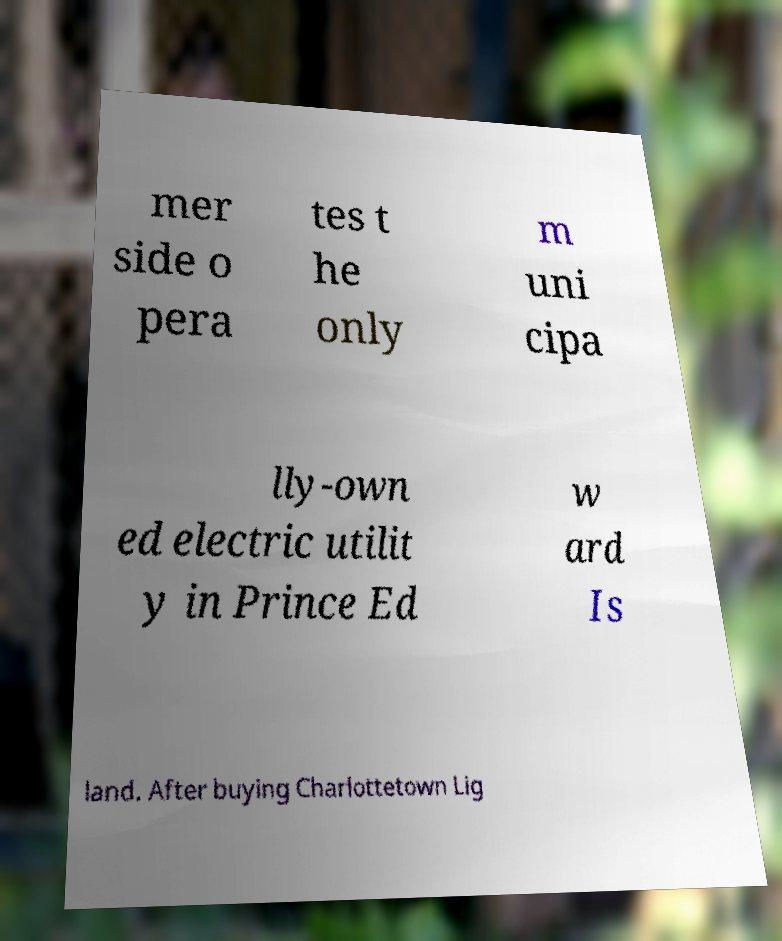There's text embedded in this image that I need extracted. Can you transcribe it verbatim? mer side o pera tes t he only m uni cipa lly-own ed electric utilit y in Prince Ed w ard Is land. After buying Charlottetown Lig 